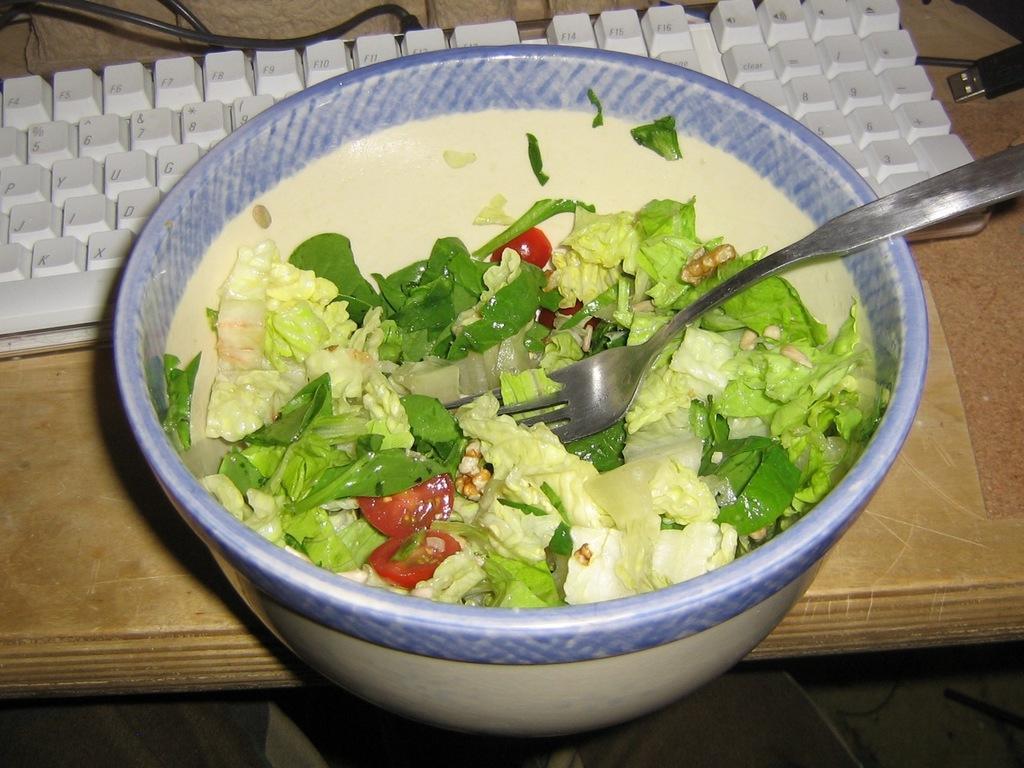Describe this image in one or two sentences. In this image there is a table in the middle. On the table there is a bowl which has some dish in it. Beside the bowl there is a keyboard with the wires. The dish contains green leaves,tomato pieces in it. There is a fork in the bowl. 